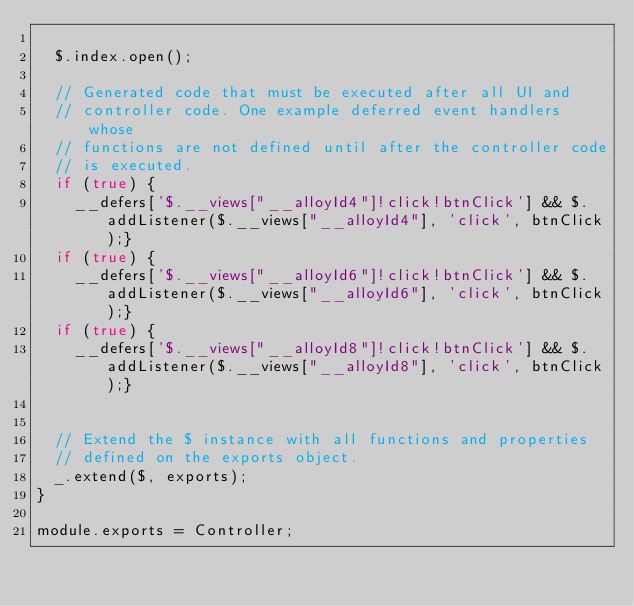<code> <loc_0><loc_0><loc_500><loc_500><_JavaScript_>
  $.index.open();

  // Generated code that must be executed after all UI and
  // controller code. One example deferred event handlers whose
  // functions are not defined until after the controller code
  // is executed.
  if (true) {
    __defers['$.__views["__alloyId4"]!click!btnClick'] && $.addListener($.__views["__alloyId4"], 'click', btnClick);}
  if (true) {
    __defers['$.__views["__alloyId6"]!click!btnClick'] && $.addListener($.__views["__alloyId6"], 'click', btnClick);}
  if (true) {
    __defers['$.__views["__alloyId8"]!click!btnClick'] && $.addListener($.__views["__alloyId8"], 'click', btnClick);}


  // Extend the $ instance with all functions and properties
  // defined on the exports object.
  _.extend($, exports);
}

module.exports = Controller;</code> 